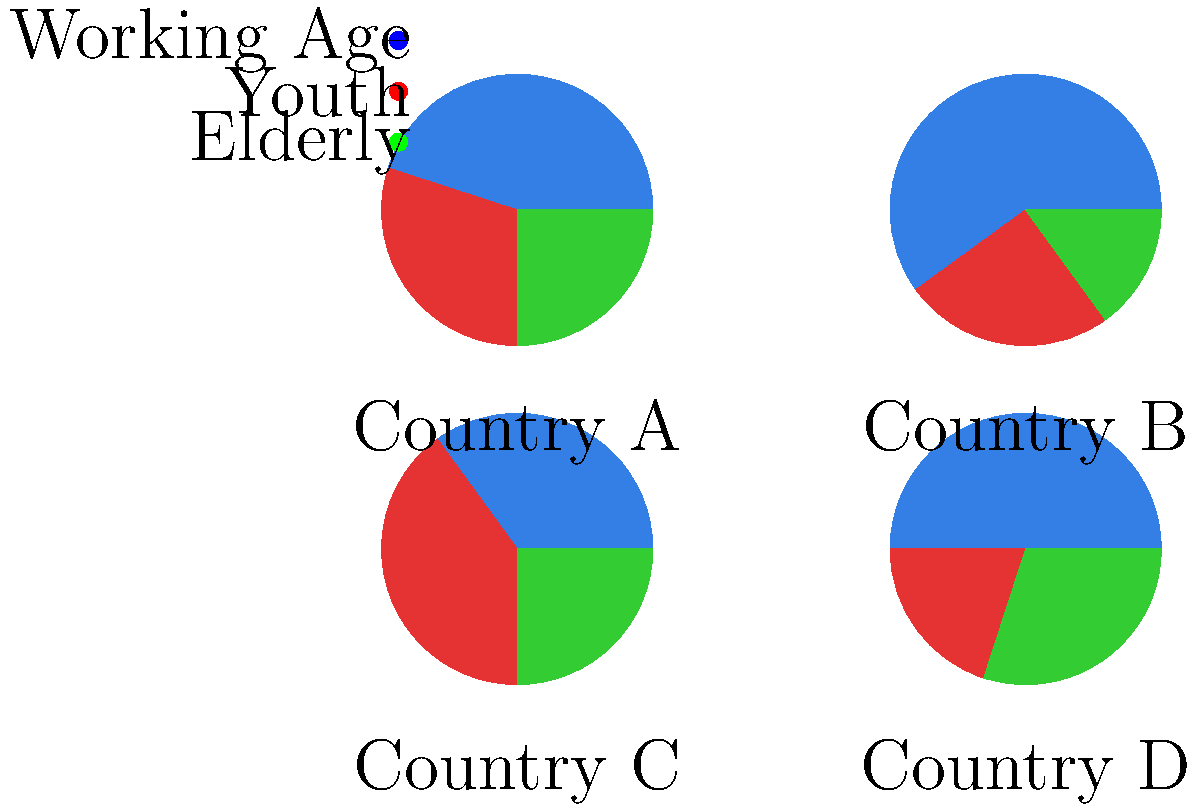As a diplomat analyzing demographic trends, which country would you identify as having the most favorable age structure for economic growth and potentially the strongest geopolitical position in the near future? To determine which country has the most favorable age structure for economic growth and potential geopolitical advantage, we need to consider the following factors:

1. Working-age population (blue): A larger proportion indicates a strong workforce and economic potential.
2. Youth population (red): A moderate proportion ensures future workforce replenishment.
3. Elderly population (green): A smaller proportion reduces the dependency ratio.

Let's analyze each country:

Country A:
- Working-age: ~45%
- Youth: ~30%
- Elderly: ~25%

Country B:
- Working-age: ~60%
- Youth: ~25%
- Elderly: ~15%

Country C:
- Working-age: ~35%
- Youth: ~40%
- Elderly: ~25%

Country D:
- Working-age: ~50%
- Youth: ~20%
- Elderly: ~30%

Country B has the most favorable age structure because:
1. It has the highest proportion of working-age population (60%), indicating a strong current workforce.
2. It has a moderate youth population (25%), ensuring future workforce replenishment.
3. It has the lowest proportion of elderly population (15%), which means a lower dependency ratio.

This demographic structure suggests that Country B has the highest potential for economic growth and, consequently, a stronger geopolitical position in the near future.
Answer: Country B 